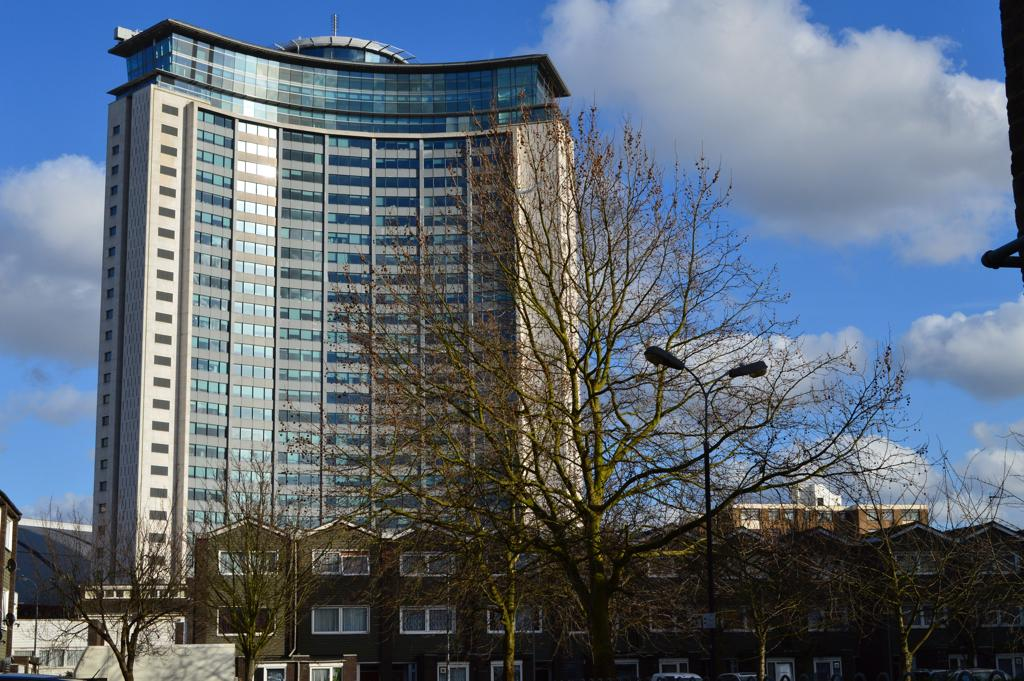What is the main subject in the front of the image? There is a dry tree in the front of the image. What can be seen in the background of the image? There are buildings and trees in the background of the image. How would you describe the sky in the image? The sky is cloudy in the image. What type of interest is being paid on the tree in the image? There is no mention of interest or financial transactions in the image; it features a dry tree and other elements in the background. 